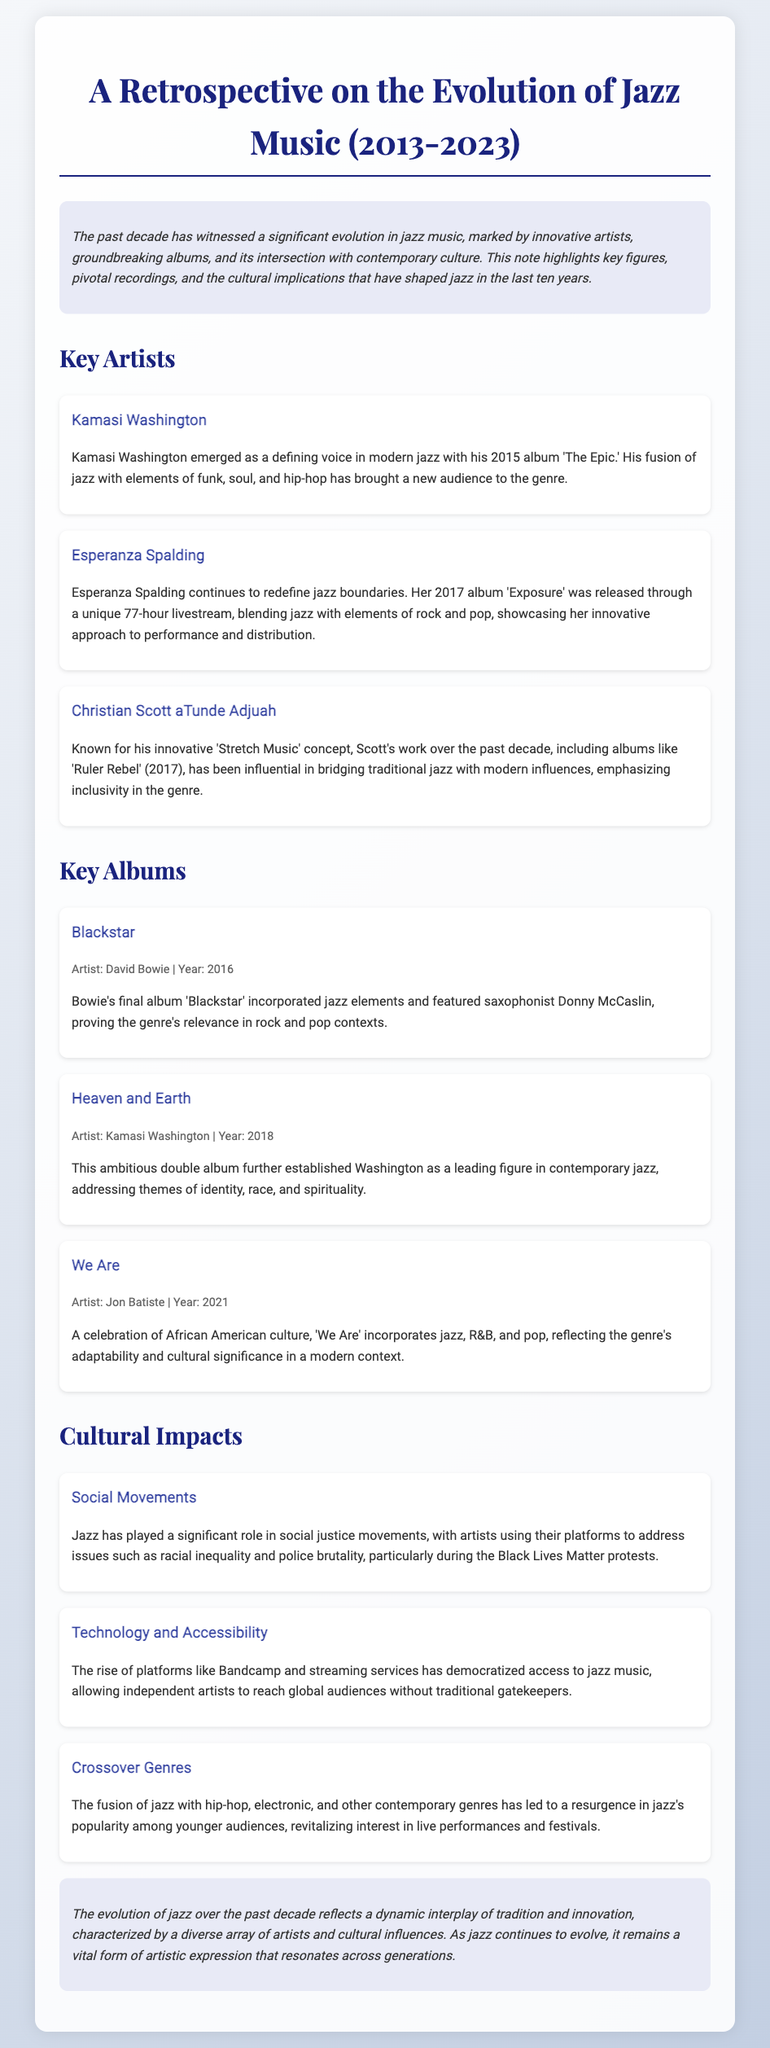What is the title of the retrospective? The title of the retrospective is 'A Retrospective on the Evolution of Jazz Music (2013-2023).'
Answer: A Retrospective on the Evolution of Jazz Music (2013-2023) Who is a defining voice in modern jazz mentioned in the document? Kamasi Washington is identified as a defining voice in modern jazz.
Answer: Kamasi Washington What year was 'Blackstar' released? The album 'Blackstar' was released in 2016.
Answer: 2016 Which artist's album was released through a 77-hour livestream? Esperanza Spalding's album 'Exposure' was released through a 77-hour livestream.
Answer: Esperanza Spalding What cultural movement has jazz played a significant role in, according to the document? Jazz has played a significant role in social justice movements.
Answer: Social justice movements How has technology impacted access to jazz music in the past decade? The rise of platforms like Bandcamp and streaming services has democratized access to jazz music.
Answer: Democratized access What genre fusion has contributed to a resurgence in jazz popularity among younger audiences? The fusion of jazz with hip-hop, electronic, and other contemporary genres has led to a resurgence.
Answer: Jazz with hip-hop and electronic Who is the artist of the album 'We Are'? The artist of the album 'We Are' is Jon Batiste.
Answer: Jon Batiste What main theme does Kamasi Washington's album 'Heaven and Earth' address? 'Heaven and Earth' addresses themes of identity, race, and spirituality.
Answer: Identity, race, and spirituality 